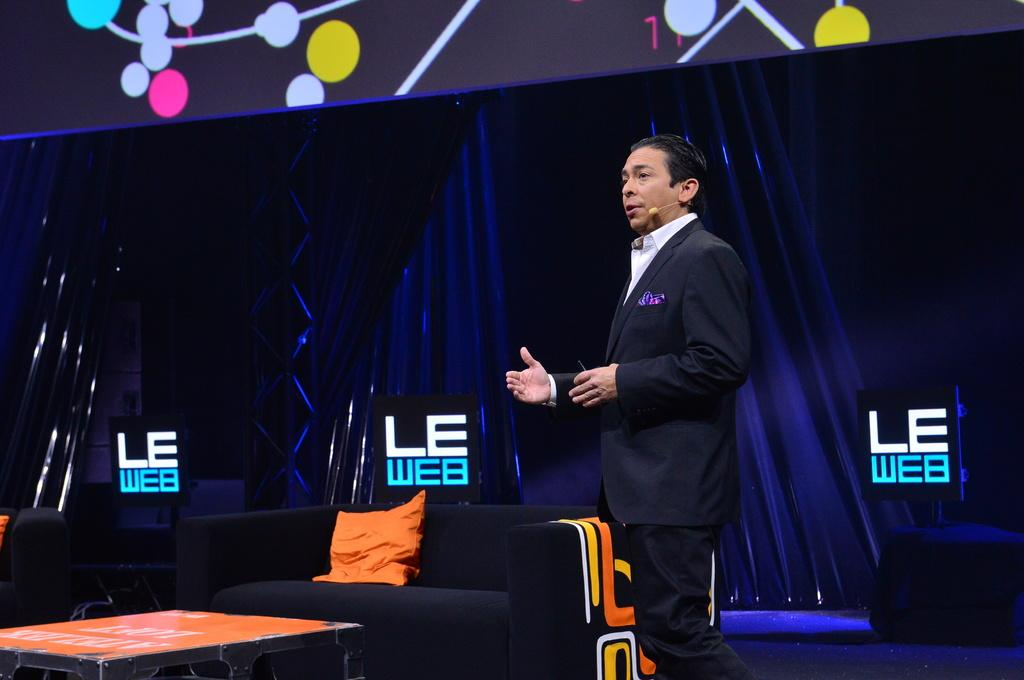Provide a one-sentence caption for the provided image. A present gives a speech at the LE Web conference. 